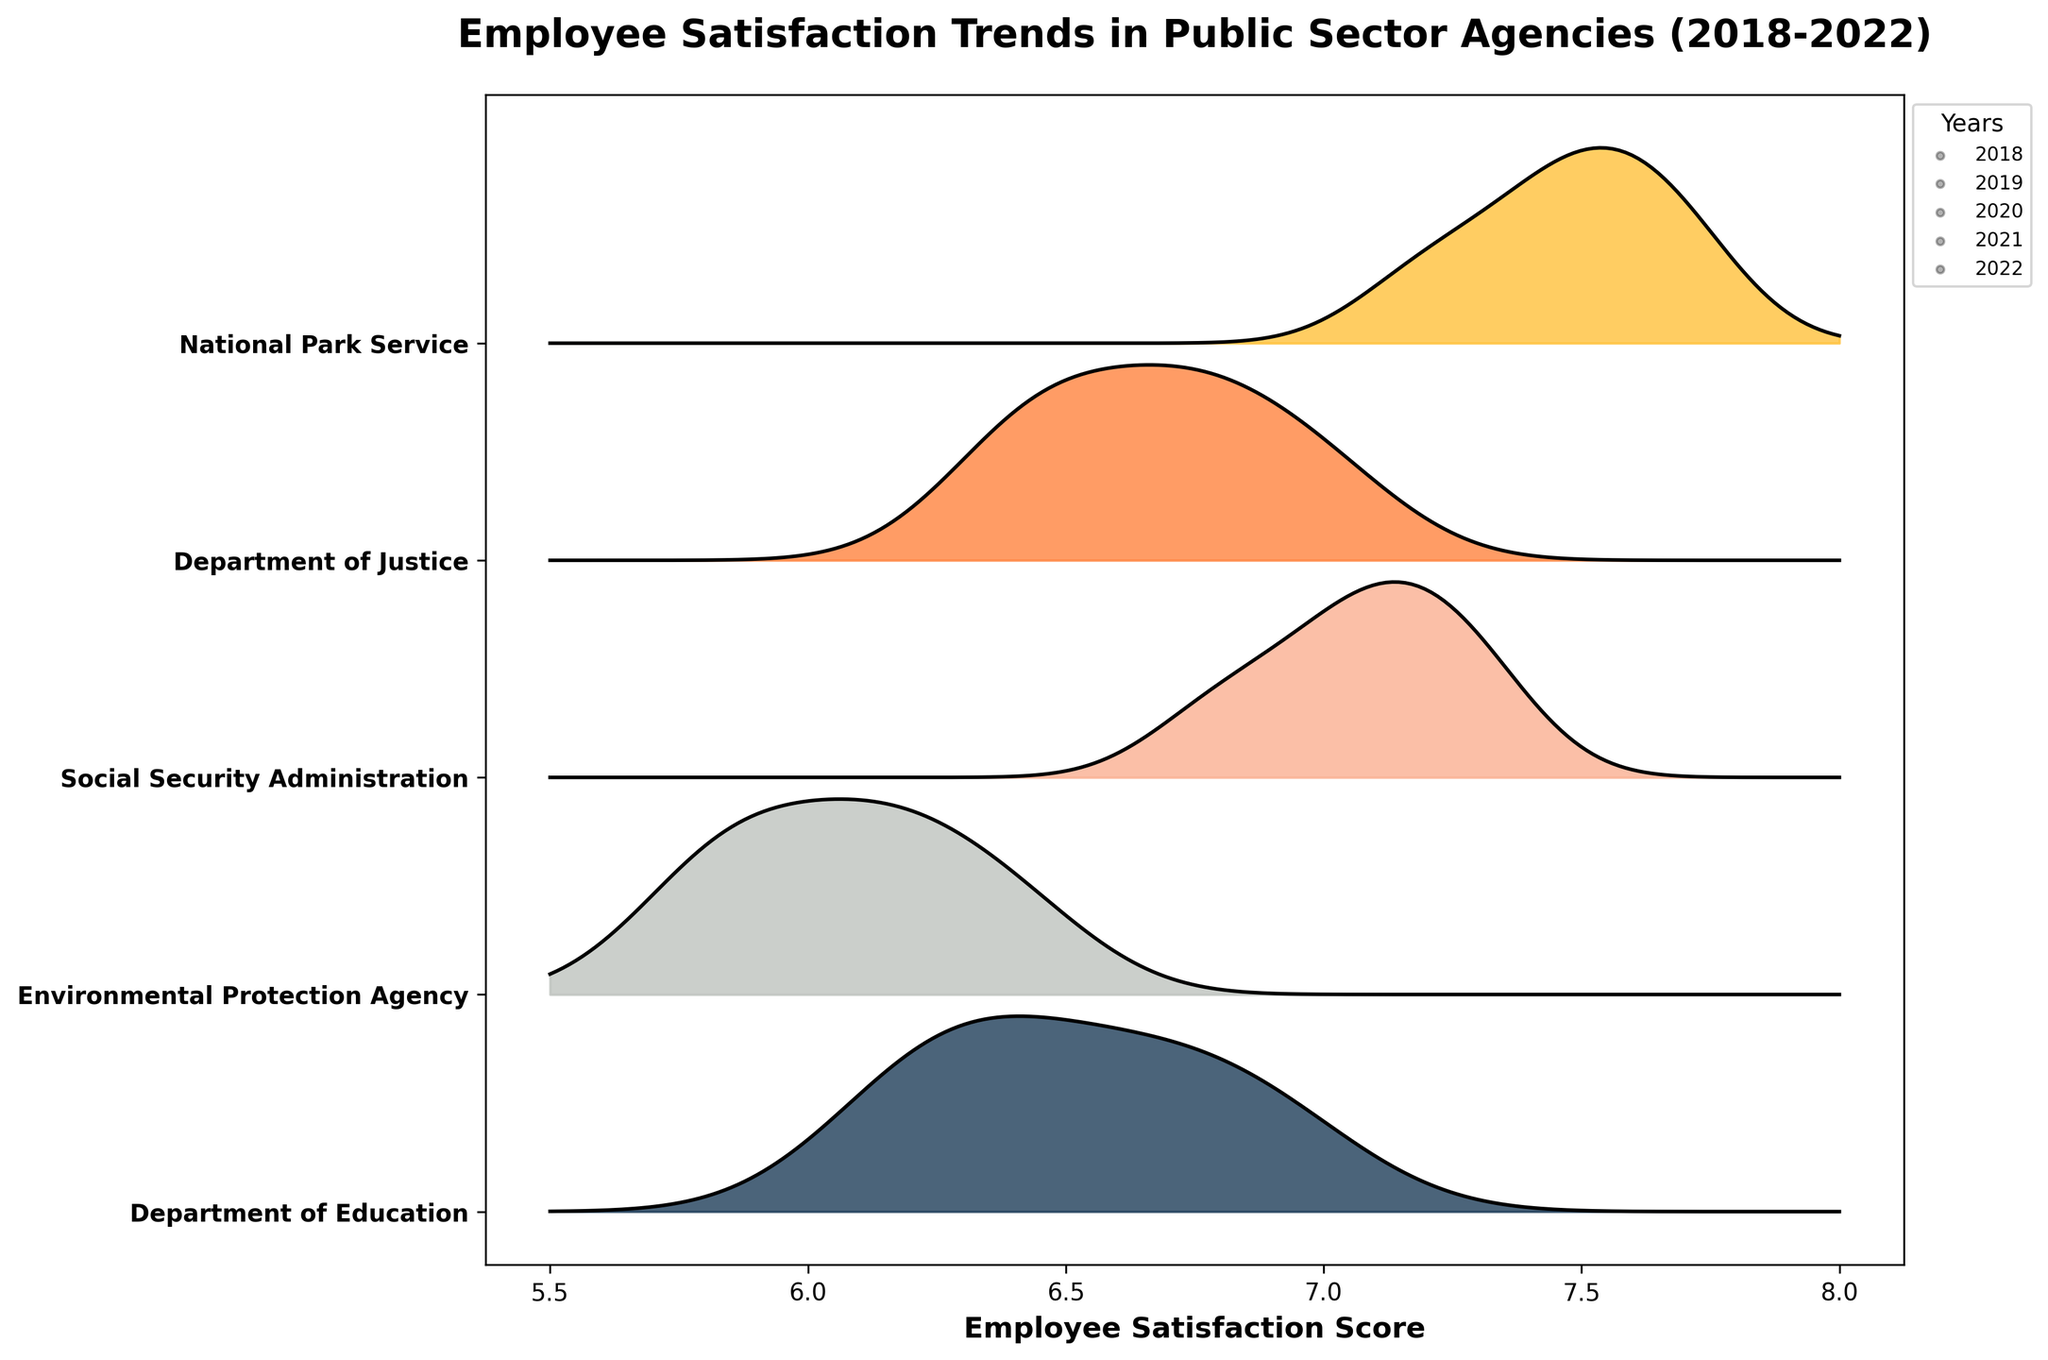Which agency shows the highest employee satisfaction in 2022? Scan through the ridgeline plot and identify which agency's peak extends the farthest to the right in 2022. The National Park Service's peak in 2022 is the furthest to the right, indicating the highest satisfaction score.
Answer: National Park Service How did the Department of Education's employee satisfaction change from 2018 to 2021? Observe the Department of Education's peaks from 2018 to 2021. The satisfaction scores were 6.2 in 2018, 6.5 in 2019, 6.3 in 2020, and 6.7 in 2021. Calculate the differences year-to-year and summarize the trend.
Answer: Increased overall, with a dip in 2020 Between the Department of Justice and the Environmental Protection Agency, which had a larger increase in satisfaction from 2018 to 2022? Compare the 2018 and 2022 satisfaction scores for both agencies. The Department of Justice increased from 6.5 to 7.0 (0.5) and the Environmental Protection Agency from 5.8 to 6.4 (0.6).
Answer: Environmental Protection Agency On average, which agency had the highest satisfaction scores between 2018 and 2022? Calculate the average of the satisfaction scores for each agency over the years. For instance, the average for the National Park Service is (7.4 + 7.6 + 7.2 + 7.5 + 7.7)/5 = 7.48, which is the highest among all agencies.
Answer: National Park Service Which agency had the smallest variation in employee satisfaction scores from 2018 to 2022? Assess the range of satisfaction scores for each agency by identifying the difference between the highest and lowest scores. The Department of Justice has scores ranging between 6.4 and 7.0, resulting in the smallest variation.
Answer: Department of Justice 